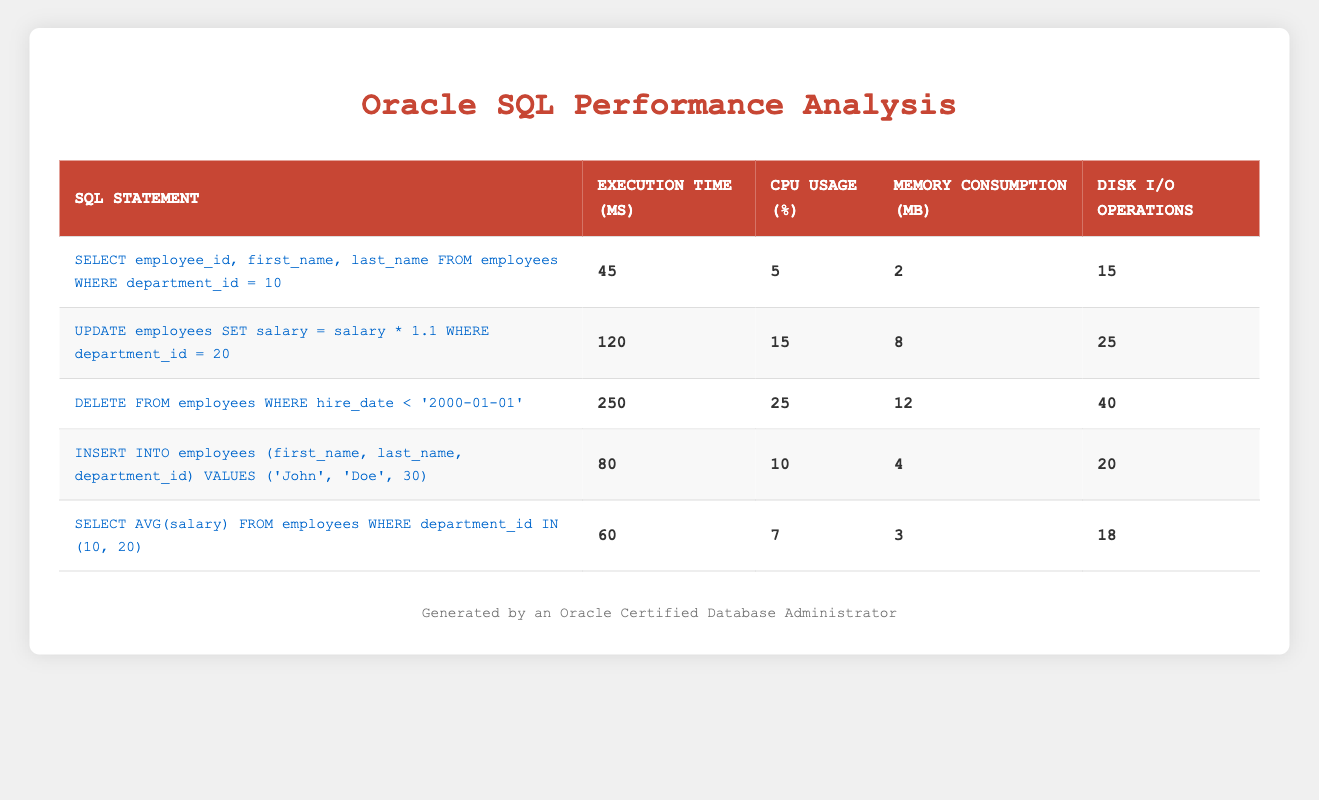What is the execution time of the DELETE statement? The execution time for the DELETE statement "DELETE FROM employees WHERE hire_date < '2000-01-01'" is clearly listed in the table. Looking at the corresponding row, the execution time is noted as 250 milliseconds.
Answer: 250 milliseconds Which SQL statement has the highest CPU usage? To find the SQL statement with the highest CPU usage, we look through the CPU usage percentage values in the table. The DELETE statement has the highest CPU usage at 25 percent.
Answer: DELETE FROM employees WHERE hire_date < '2000-01-01' What is the average execution time for the SELECT statements? The execution times for the SELECT statements are 45 ms and 60 ms. To calculate the average, we sum these values: 45 + 60 = 105 ms, and then divide by the number of SELECT statements, which is 2. So, the average execution time is 105 / 2 = 52.5 ms.
Answer: 52.5 ms Does the INSERT statement consume more memory than the average memory consumption of all the queries? First, we need to find the memory consumption of the INSERT statement, which is 4 MB. Next, we calculate the average memory consumption for all queries: (2 + 8 + 12 + 4 + 3) / 5 = 29 / 5 = 5.8 MB. Since 4 MB is less than 5.8 MB, the answer is no.
Answer: No What is the total number of disk I/O operations for all queries combined? To find the total number of disk I/O operations, we add the disk I/O operations for each query: 15 + 25 + 40 + 20 + 18 = 118. Therefore, the total number of disk I/O operations for all queries combined is 118.
Answer: 118 